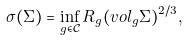Convert formula to latex. <formula><loc_0><loc_0><loc_500><loc_500>\sigma ( \Sigma ) = \inf _ { g \in { \mathcal { C } } } R _ { g } ( v o l _ { g } \Sigma ) ^ { 2 / 3 } ,</formula> 